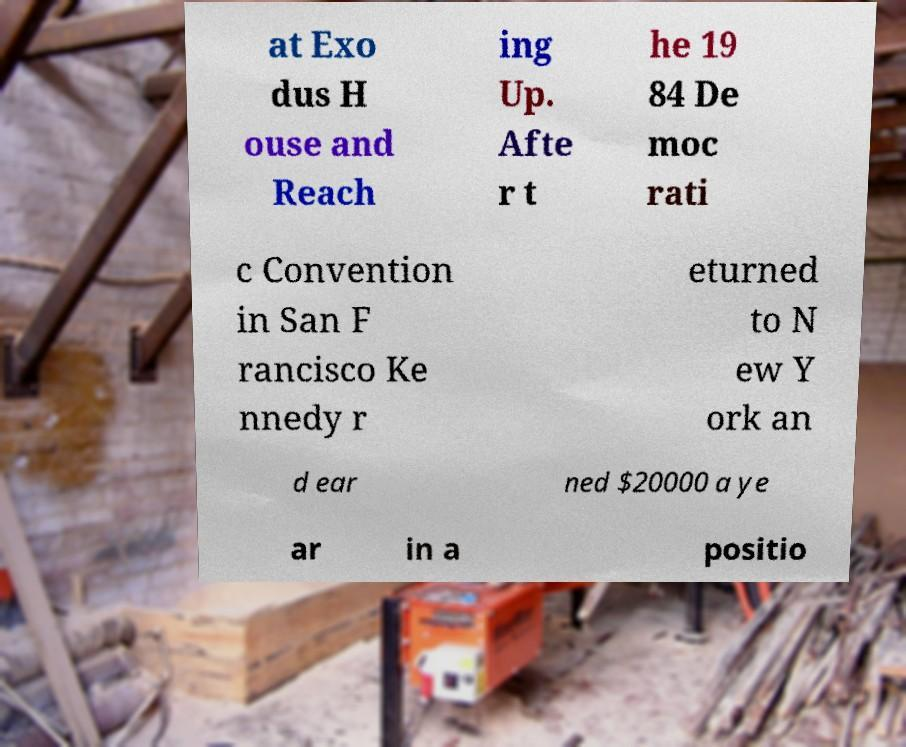Please read and relay the text visible in this image. What does it say? at Exo dus H ouse and Reach ing Up. Afte r t he 19 84 De moc rati c Convention in San F rancisco Ke nnedy r eturned to N ew Y ork an d ear ned $20000 a ye ar in a positio 